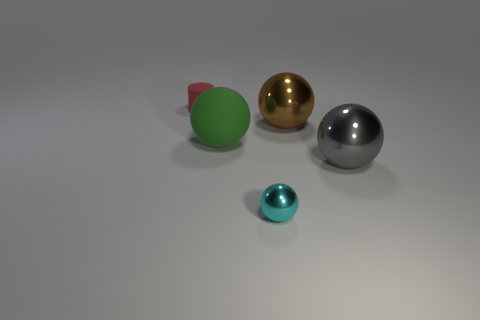What number of things are either big metallic things that are on the left side of the big gray shiny object or green rubber things?
Your answer should be compact. 2. There is a tiny red object that is on the left side of the sphere that is to the right of the brown thing; what shape is it?
Provide a succinct answer. Cylinder. Is there a rubber thing of the same size as the brown shiny ball?
Offer a very short reply. Yes. Are there more gray spheres than large purple metallic balls?
Your answer should be very brief. Yes. Is the size of the shiny thing in front of the big gray metallic sphere the same as the thing behind the large brown thing?
Offer a terse response. Yes. How many things are both to the left of the matte sphere and in front of the green rubber ball?
Offer a terse response. 0. The small object that is the same shape as the big green thing is what color?
Offer a terse response. Cyan. Are there fewer small red cylinders than small brown cubes?
Provide a short and direct response. No. There is a cyan ball; is its size the same as the sphere on the left side of the small cyan metallic ball?
Make the answer very short. No. What is the color of the small object that is on the right side of the red matte cylinder behind the large rubber sphere?
Offer a terse response. Cyan. 